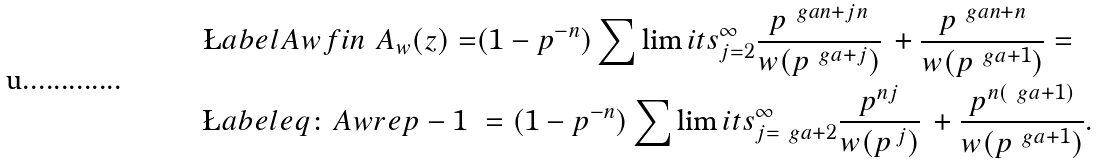Convert formula to latex. <formula><loc_0><loc_0><loc_500><loc_500>\L a b e l { A w f i n } \ A _ { w } ( z ) = & ( 1 - p ^ { - n } ) \sum \lim i t s _ { j = 2 } ^ { \infty } \frac { p ^ { \ g a n + j n } } { w ( p ^ { \ g a + j } ) } \, + \frac { p ^ { \ g a n + n } } { w ( p ^ { \ g a + 1 } ) } = \\ \L a b e l { e q \colon A w r e p - 1 } \ & = ( 1 - p ^ { - n } ) \sum \lim i t s _ { j = \ g a + 2 } ^ { \infty } \frac { p ^ { n j } } { w ( p ^ { \, j } ) } \, + \frac { p ^ { n ( \ g a + 1 ) } } { w ( p ^ { \ g a + 1 } ) } .</formula> 